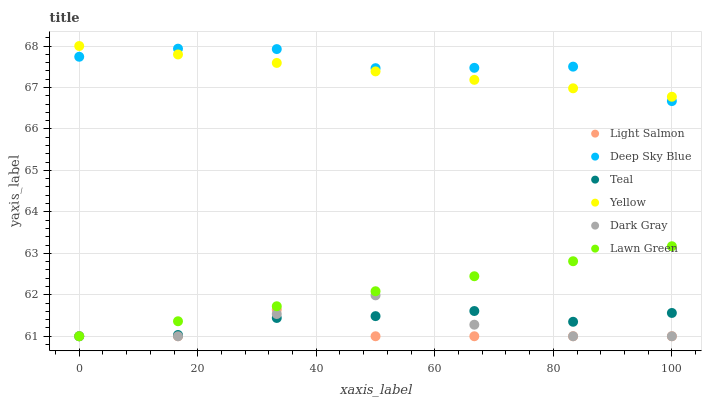Does Light Salmon have the minimum area under the curve?
Answer yes or no. Yes. Does Deep Sky Blue have the maximum area under the curve?
Answer yes or no. Yes. Does Deep Sky Blue have the minimum area under the curve?
Answer yes or no. No. Does Light Salmon have the maximum area under the curve?
Answer yes or no. No. Is Lawn Green the smoothest?
Answer yes or no. Yes. Is Light Salmon the roughest?
Answer yes or no. Yes. Is Deep Sky Blue the smoothest?
Answer yes or no. No. Is Deep Sky Blue the roughest?
Answer yes or no. No. Does Lawn Green have the lowest value?
Answer yes or no. Yes. Does Deep Sky Blue have the lowest value?
Answer yes or no. No. Does Yellow have the highest value?
Answer yes or no. Yes. Does Light Salmon have the highest value?
Answer yes or no. No. Is Dark Gray less than Deep Sky Blue?
Answer yes or no. Yes. Is Yellow greater than Light Salmon?
Answer yes or no. Yes. Does Light Salmon intersect Lawn Green?
Answer yes or no. Yes. Is Light Salmon less than Lawn Green?
Answer yes or no. No. Is Light Salmon greater than Lawn Green?
Answer yes or no. No. Does Dark Gray intersect Deep Sky Blue?
Answer yes or no. No. 